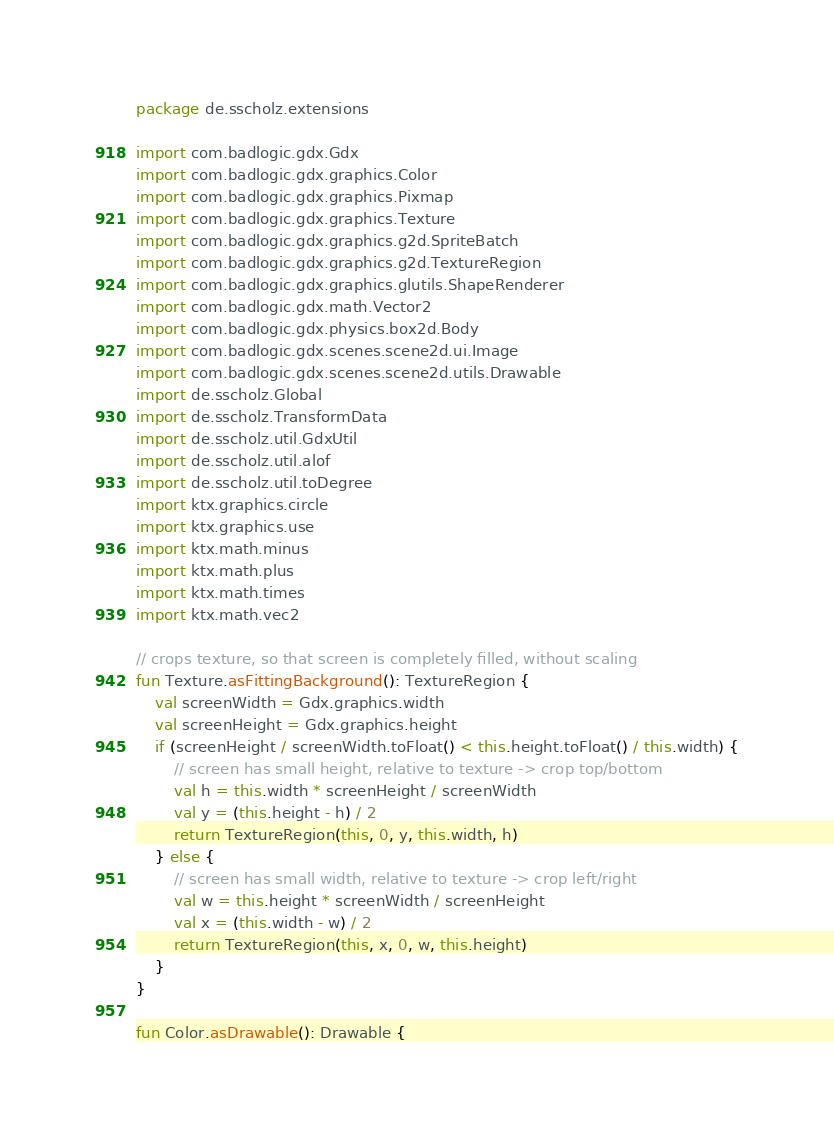<code> <loc_0><loc_0><loc_500><loc_500><_Kotlin_>package de.sscholz.extensions

import com.badlogic.gdx.Gdx
import com.badlogic.gdx.graphics.Color
import com.badlogic.gdx.graphics.Pixmap
import com.badlogic.gdx.graphics.Texture
import com.badlogic.gdx.graphics.g2d.SpriteBatch
import com.badlogic.gdx.graphics.g2d.TextureRegion
import com.badlogic.gdx.graphics.glutils.ShapeRenderer
import com.badlogic.gdx.math.Vector2
import com.badlogic.gdx.physics.box2d.Body
import com.badlogic.gdx.scenes.scene2d.ui.Image
import com.badlogic.gdx.scenes.scene2d.utils.Drawable
import de.sscholz.Global
import de.sscholz.TransformData
import de.sscholz.util.GdxUtil
import de.sscholz.util.alof
import de.sscholz.util.toDegree
import ktx.graphics.circle
import ktx.graphics.use
import ktx.math.minus
import ktx.math.plus
import ktx.math.times
import ktx.math.vec2

// crops texture, so that screen is completely filled, without scaling
fun Texture.asFittingBackground(): TextureRegion {
    val screenWidth = Gdx.graphics.width
    val screenHeight = Gdx.graphics.height
    if (screenHeight / screenWidth.toFloat() < this.height.toFloat() / this.width) {
        // screen has small height, relative to texture -> crop top/bottom
        val h = this.width * screenHeight / screenWidth
        val y = (this.height - h) / 2
        return TextureRegion(this, 0, y, this.width, h)
    } else {
        // screen has small width, relative to texture -> crop left/right
        val w = this.height * screenWidth / screenHeight
        val x = (this.width - w) / 2
        return TextureRegion(this, x, 0, w, this.height)
    }
}

fun Color.asDrawable(): Drawable {</code> 